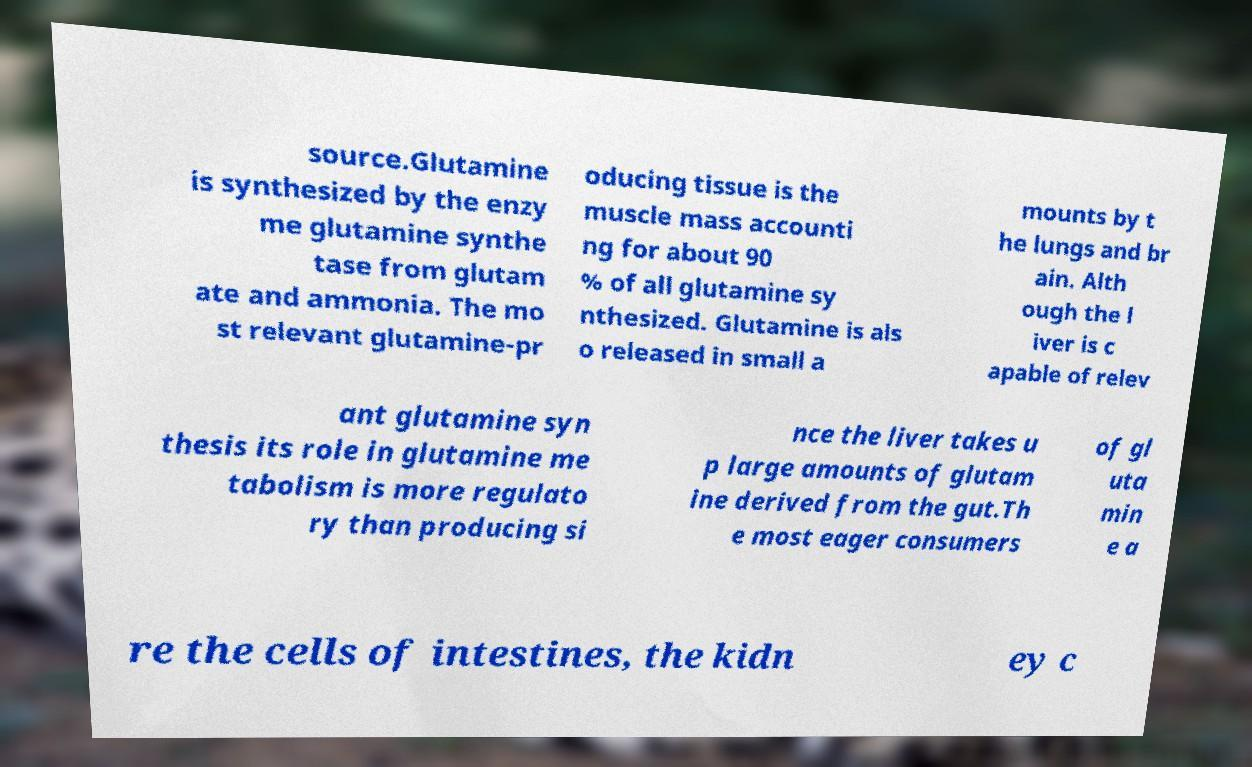Could you extract and type out the text from this image? source.Glutamine is synthesized by the enzy me glutamine synthe tase from glutam ate and ammonia. The mo st relevant glutamine-pr oducing tissue is the muscle mass accounti ng for about 90 % of all glutamine sy nthesized. Glutamine is als o released in small a mounts by t he lungs and br ain. Alth ough the l iver is c apable of relev ant glutamine syn thesis its role in glutamine me tabolism is more regulato ry than producing si nce the liver takes u p large amounts of glutam ine derived from the gut.Th e most eager consumers of gl uta min e a re the cells of intestines, the kidn ey c 